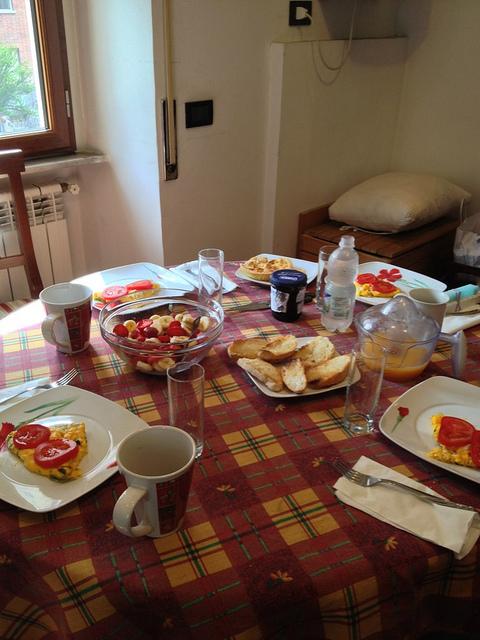Where is this?
Give a very brief answer. Home. How many types of cups are there?
Be succinct. 2. Is this a buffet?
Give a very brief answer. No. Was this meal prepared at home?
Write a very short answer. Yes. 